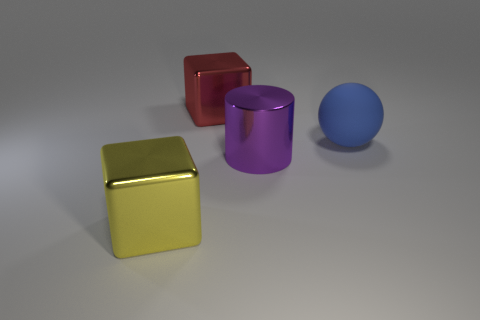Do the purple thing and the blue thing have the same size?
Ensure brevity in your answer.  Yes. There is a thing that is both right of the big red object and behind the purple cylinder; what size is it?
Your answer should be very brief. Large. Is the number of big purple things that are behind the large yellow metal thing greater than the number of large yellow metal cubes that are on the right side of the big purple metal thing?
Your response must be concise. Yes. The other thing that is the same shape as the big yellow object is what color?
Provide a succinct answer. Red. What number of purple things are there?
Provide a succinct answer. 1. Does the cube that is behind the big yellow metal cube have the same material as the blue object?
Offer a very short reply. No. Is there anything else that is the same material as the blue sphere?
Provide a short and direct response. No. How many big cubes are to the right of the metallic block in front of the blue object behind the large metal cylinder?
Your response must be concise. 1. How big is the blue thing?
Your answer should be compact. Large. Does the matte object have the same color as the cylinder?
Give a very brief answer. No. 